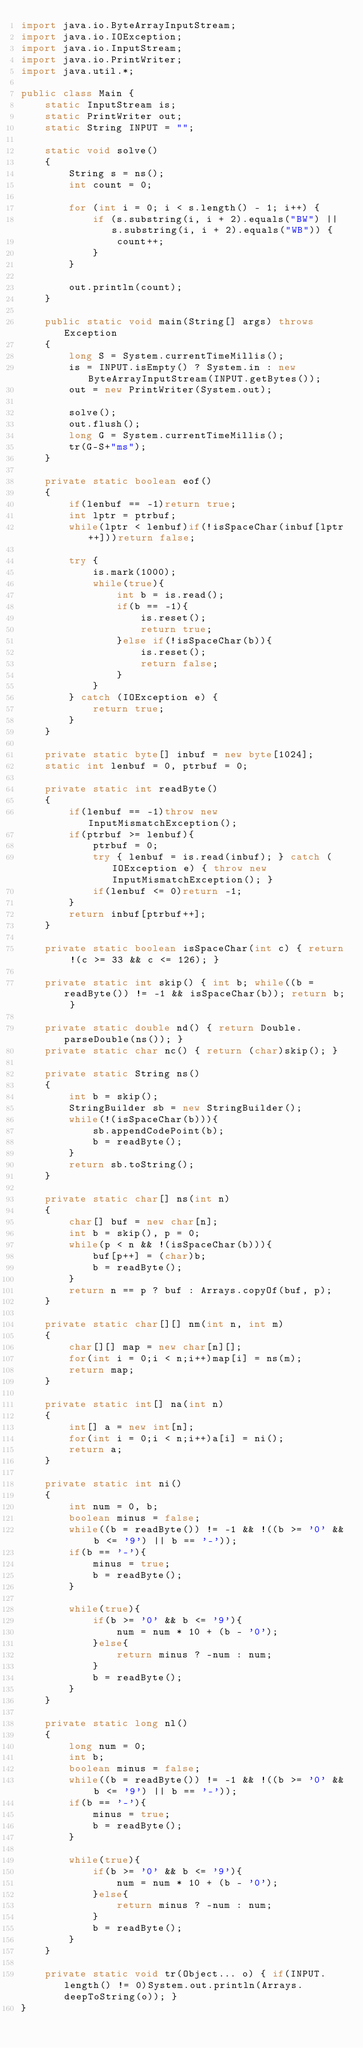Convert code to text. <code><loc_0><loc_0><loc_500><loc_500><_Java_>import java.io.ByteArrayInputStream;
import java.io.IOException;
import java.io.InputStream;
import java.io.PrintWriter;
import java.util.*;

public class Main {
    static InputStream is;
    static PrintWriter out;
    static String INPUT = "";

    static void solve()
    {
        String s = ns();
        int count = 0;

        for (int i = 0; i < s.length() - 1; i++) {
            if (s.substring(i, i + 2).equals("BW") || s.substring(i, i + 2).equals("WB")) {
                count++;
            }
        }

        out.println(count);
    }

    public static void main(String[] args) throws Exception
    {
        long S = System.currentTimeMillis();
        is = INPUT.isEmpty() ? System.in : new ByteArrayInputStream(INPUT.getBytes());
        out = new PrintWriter(System.out);

        solve();
        out.flush();
        long G = System.currentTimeMillis();
        tr(G-S+"ms");
    }

    private static boolean eof()
    {
        if(lenbuf == -1)return true;
        int lptr = ptrbuf;
        while(lptr < lenbuf)if(!isSpaceChar(inbuf[lptr++]))return false;

        try {
            is.mark(1000);
            while(true){
                int b = is.read();
                if(b == -1){
                    is.reset();
                    return true;
                }else if(!isSpaceChar(b)){
                    is.reset();
                    return false;
                }
            }
        } catch (IOException e) {
            return true;
        }
    }

    private static byte[] inbuf = new byte[1024];
    static int lenbuf = 0, ptrbuf = 0;

    private static int readByte()
    {
        if(lenbuf == -1)throw new InputMismatchException();
        if(ptrbuf >= lenbuf){
            ptrbuf = 0;
            try { lenbuf = is.read(inbuf); } catch (IOException e) { throw new InputMismatchException(); }
            if(lenbuf <= 0)return -1;
        }
        return inbuf[ptrbuf++];
    }

    private static boolean isSpaceChar(int c) { return !(c >= 33 && c <= 126); }

    private static int skip() { int b; while((b = readByte()) != -1 && isSpaceChar(b)); return b; }

    private static double nd() { return Double.parseDouble(ns()); }
    private static char nc() { return (char)skip(); }

    private static String ns()
    {
        int b = skip();
        StringBuilder sb = new StringBuilder();
        while(!(isSpaceChar(b))){
            sb.appendCodePoint(b);
            b = readByte();
        }
        return sb.toString();
    }

    private static char[] ns(int n)
    {
        char[] buf = new char[n];
        int b = skip(), p = 0;
        while(p < n && !(isSpaceChar(b))){
            buf[p++] = (char)b;
            b = readByte();
        }
        return n == p ? buf : Arrays.copyOf(buf, p);
    }

    private static char[][] nm(int n, int m)
    {
        char[][] map = new char[n][];
        for(int i = 0;i < n;i++)map[i] = ns(m);
        return map;
    }

    private static int[] na(int n)
    {
        int[] a = new int[n];
        for(int i = 0;i < n;i++)a[i] = ni();
        return a;
    }

    private static int ni()
    {
        int num = 0, b;
        boolean minus = false;
        while((b = readByte()) != -1 && !((b >= '0' && b <= '9') || b == '-'));
        if(b == '-'){
            minus = true;
            b = readByte();
        }

        while(true){
            if(b >= '0' && b <= '9'){
                num = num * 10 + (b - '0');
            }else{
                return minus ? -num : num;
            }
            b = readByte();
        }
    }

    private static long nl()
    {
        long num = 0;
        int b;
        boolean minus = false;
        while((b = readByte()) != -1 && !((b >= '0' && b <= '9') || b == '-'));
        if(b == '-'){
            minus = true;
            b = readByte();
        }

        while(true){
            if(b >= '0' && b <= '9'){
                num = num * 10 + (b - '0');
            }else{
                return minus ? -num : num;
            }
            b = readByte();
        }
    }

    private static void tr(Object... o) { if(INPUT.length() != 0)System.out.println(Arrays.deepToString(o)); }
}
</code> 